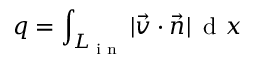Convert formula to latex. <formula><loc_0><loc_0><loc_500><loc_500>q = \int _ { L _ { i n } } | \vec { v } \cdot \vec { n } | \, { d } x</formula> 